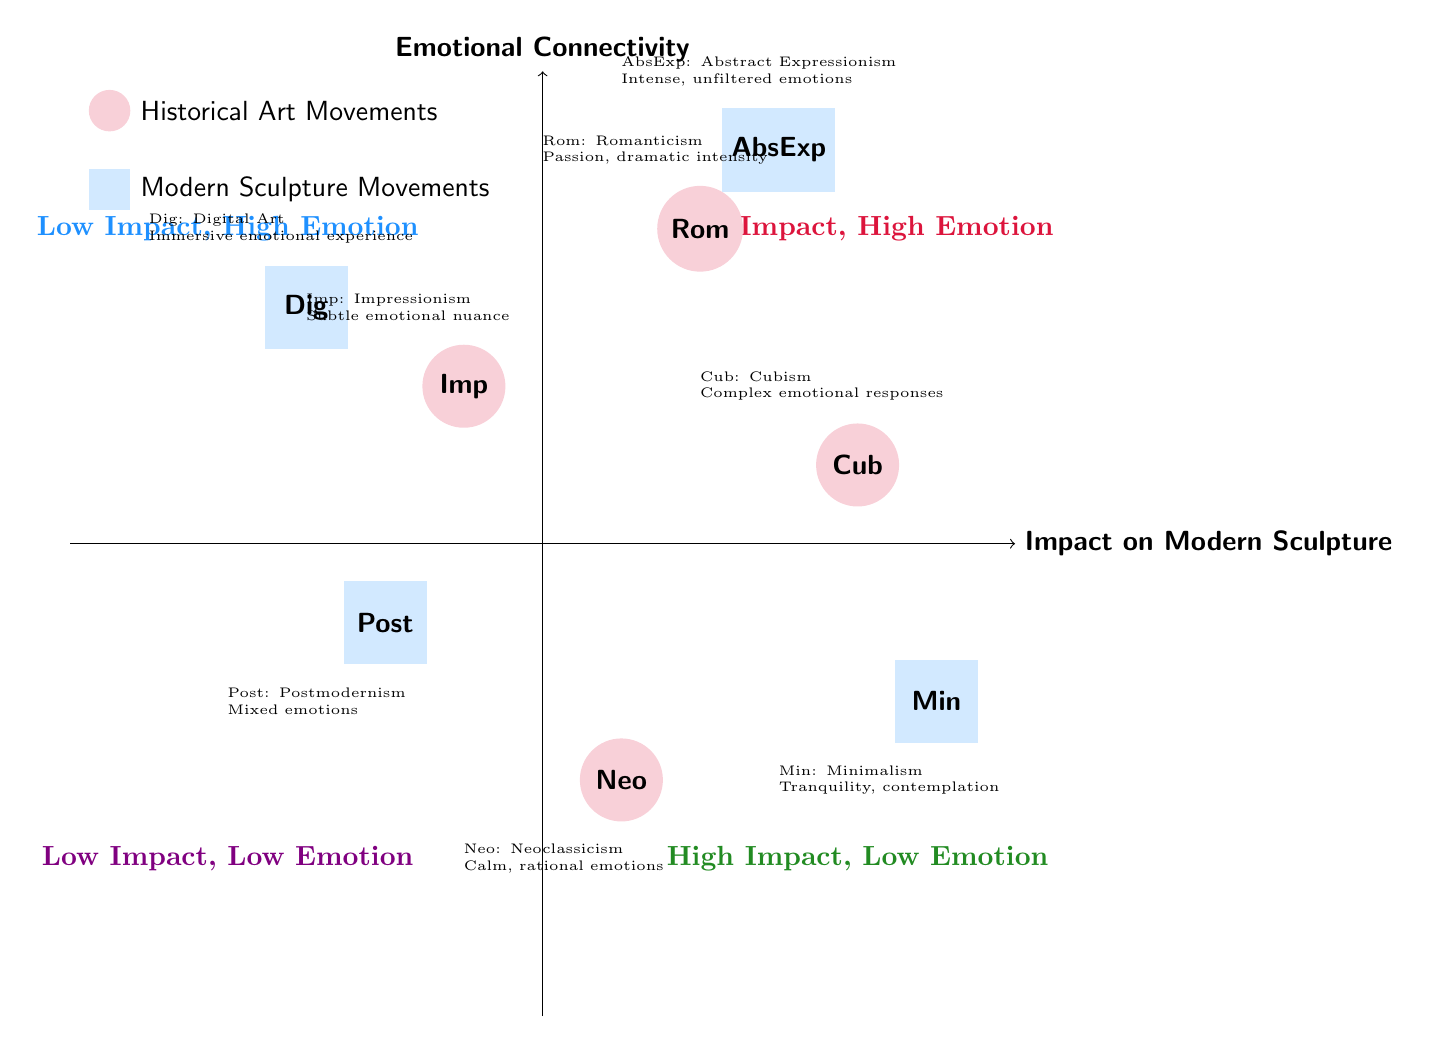What historical art movement is located in the quadrant with high impact and low emotion? The diagram indicates that Neoclassicism (Neo) is positioned in the quadrant where there is high impact on modern sculpture but low emotional connectivity.
Answer: Neoclassicism How many modern sculpture movements are displayed in the diagram? By counting the rectangles representing modern sculpture movements, there are four labeled movements: Abstract Expressionism (AbsExp), Minimalism (Min), Postmodernism (Post), and Digital Art (Dig).
Answer: Four Which modern sculpture movement induces mixed emotions? The diagram specifies that Postmodernism (Post) is the movement that elicits mixed emotions, positioned in the quadrant reflecting high emotional connectivity but low impact.
Answer: Postmodernism What type of emotional connectivity is associated with Cubism? The annotation for Cubism (Cub) suggests that it creates complex emotional responses, which means that its emotional connectivity is intellectually engaging and multifaceted.
Answer: Complex emotional responses Which historical art movement emphasizes calm and rational emotions? Neoclassicism (Neo) is noted in the diagram for emphasizing calm and rational emotions, denoting a serene but distant feel in modern sculptures.
Answer: Neoclassicism What impact does Impressionism have on modern sculpture? The diagram shows that Impressionism (Imp) introduces a sense of spontaneity and movement, indicating a notable, though not overly emotional, impact on modern sculpture.
Answer: Spontaneity and movement How is Digital Art's emotional core described? Digital Art (Dig) is characterized by engaging viewers through interactivity, thus evoking a personal and immersive emotional experience, as noted in the diagram.
Answer: Immersive emotional experience Which quadrant contains movements with high impact and high emotion? The upper right quadrant of the diagram represents high impact and high emotion, where Romanticism (Rom) and Abstract Expressionism (AbsExp) are positioned.
Answer: Romanticism and Abstract Expressionism 